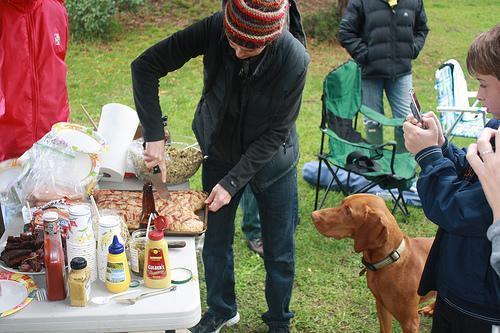How many pets?
Give a very brief answer. 1. 